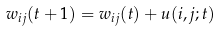<formula> <loc_0><loc_0><loc_500><loc_500>w _ { i j } ( t + 1 ) = w _ { i j } ( t ) + u ( i , j ; t )</formula> 